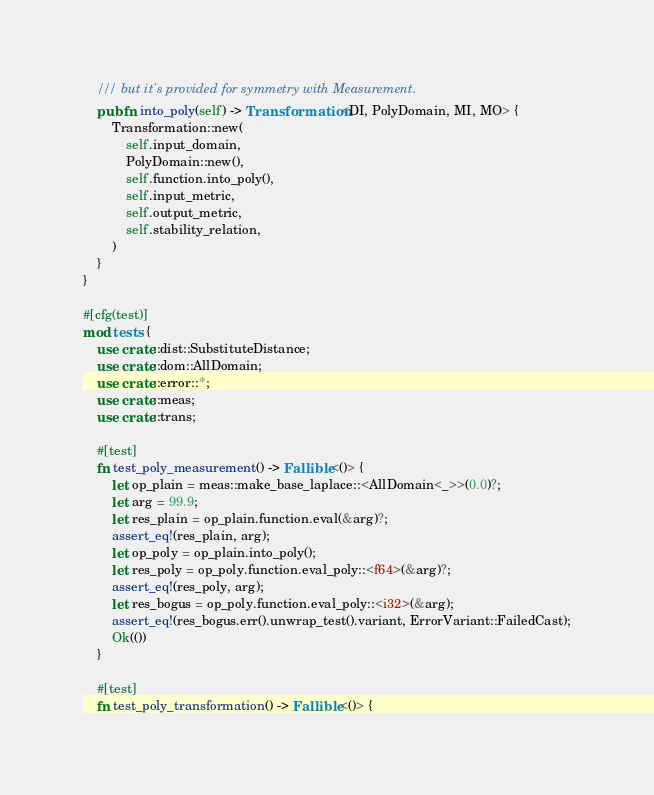Convert code to text. <code><loc_0><loc_0><loc_500><loc_500><_Rust_>    /// but it's provided for symmetry with Measurement.
    pub fn into_poly(self) -> Transformation<DI, PolyDomain, MI, MO> {
        Transformation::new(
            self.input_domain,
            PolyDomain::new(),
            self.function.into_poly(),
            self.input_metric,
            self.output_metric,
            self.stability_relation,
        )
    }
}

#[cfg(test)]
mod tests {
    use crate::dist::SubstituteDistance;
    use crate::dom::AllDomain;
    use crate::error::*;
    use crate::meas;
    use crate::trans;

    #[test]
    fn test_poly_measurement() -> Fallible<()> {
        let op_plain = meas::make_base_laplace::<AllDomain<_>>(0.0)?;
        let arg = 99.9;
        let res_plain = op_plain.function.eval(&arg)?;
        assert_eq!(res_plain, arg);
        let op_poly = op_plain.into_poly();
        let res_poly = op_poly.function.eval_poly::<f64>(&arg)?;
        assert_eq!(res_poly, arg);
        let res_bogus = op_poly.function.eval_poly::<i32>(&arg);
        assert_eq!(res_bogus.err().unwrap_test().variant, ErrorVariant::FailedCast);
        Ok(())
    }

    #[test]
    fn test_poly_transformation() -> Fallible<()> {</code> 